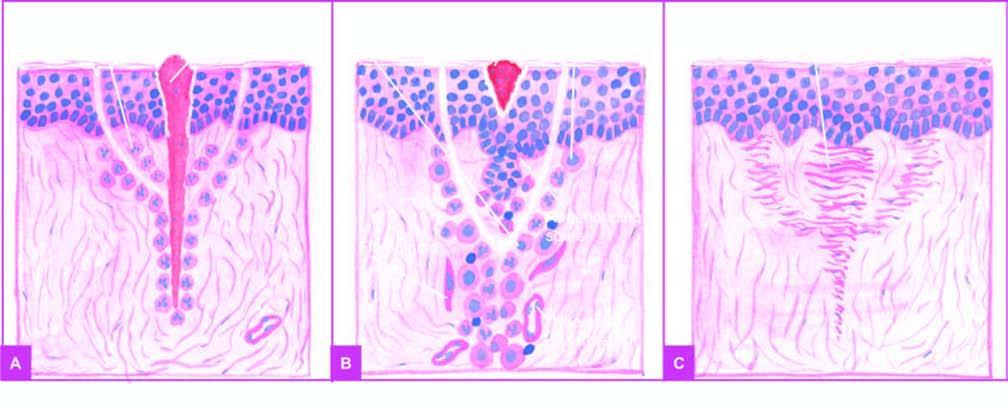do numbers migrate along the incised margin on either side as well as around the suture track?
Answer the question using a single word or phrase. No 